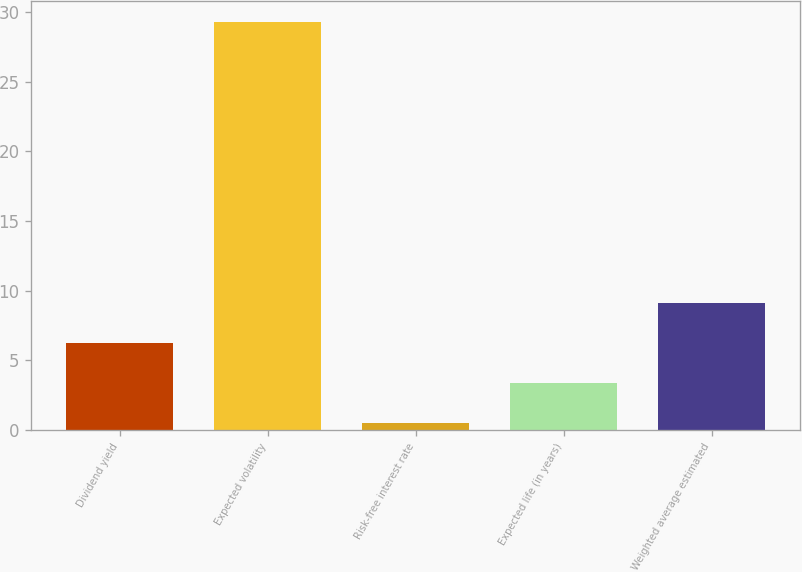Convert chart to OTSL. <chart><loc_0><loc_0><loc_500><loc_500><bar_chart><fcel>Dividend yield<fcel>Expected volatility<fcel>Risk-free interest rate<fcel>Expected life (in years)<fcel>Weighted average estimated<nl><fcel>6.23<fcel>29.3<fcel>0.47<fcel>3.35<fcel>9.11<nl></chart> 